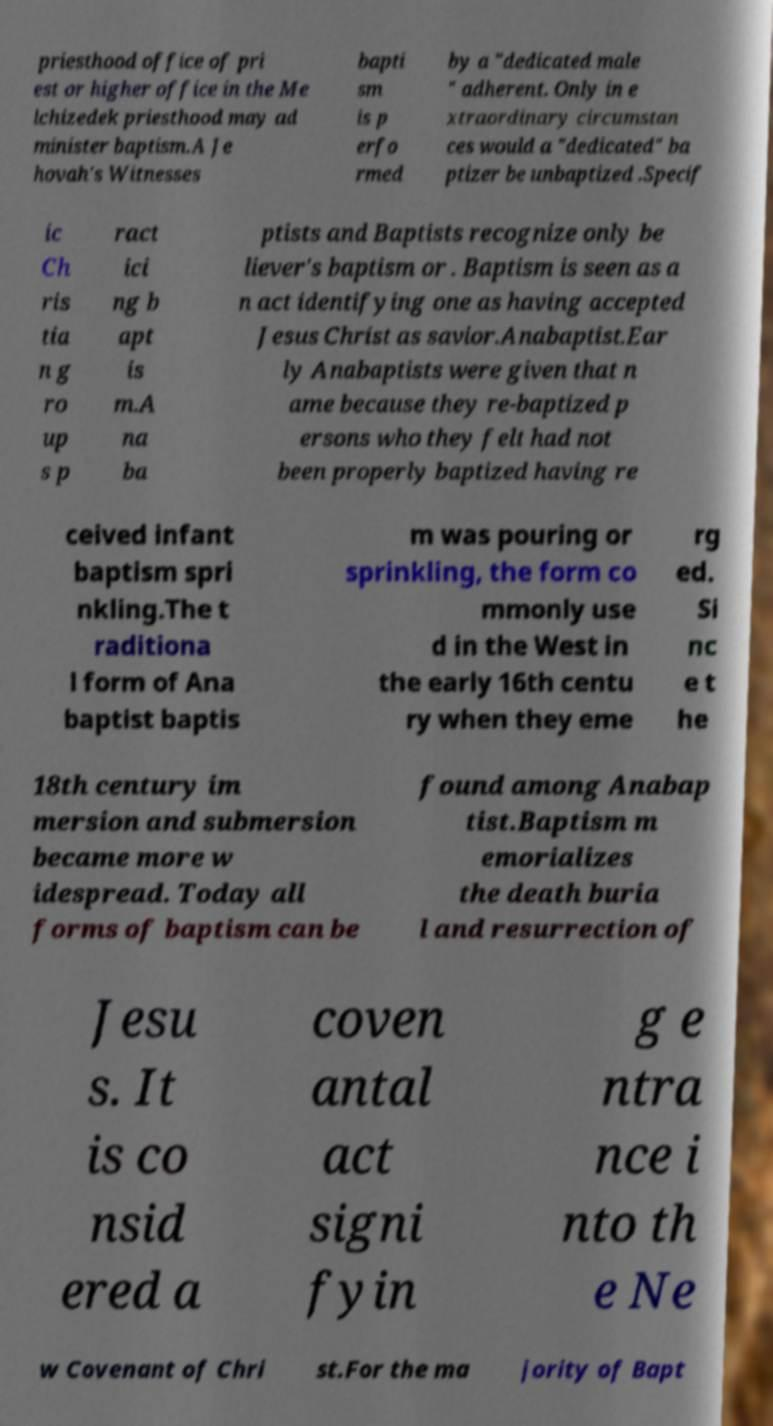What messages or text are displayed in this image? I need them in a readable, typed format. priesthood office of pri est or higher office in the Me lchizedek priesthood may ad minister baptism.A Je hovah's Witnesses bapti sm is p erfo rmed by a "dedicated male " adherent. Only in e xtraordinary circumstan ces would a "dedicated" ba ptizer be unbaptized .Specif ic Ch ris tia n g ro up s p ract ici ng b apt is m.A na ba ptists and Baptists recognize only be liever's baptism or . Baptism is seen as a n act identifying one as having accepted Jesus Christ as savior.Anabaptist.Ear ly Anabaptists were given that n ame because they re-baptized p ersons who they felt had not been properly baptized having re ceived infant baptism spri nkling.The t raditiona l form of Ana baptist baptis m was pouring or sprinkling, the form co mmonly use d in the West in the early 16th centu ry when they eme rg ed. Si nc e t he 18th century im mersion and submersion became more w idespread. Today all forms of baptism can be found among Anabap tist.Baptism m emorializes the death buria l and resurrection of Jesu s. It is co nsid ered a coven antal act signi fyin g e ntra nce i nto th e Ne w Covenant of Chri st.For the ma jority of Bapt 